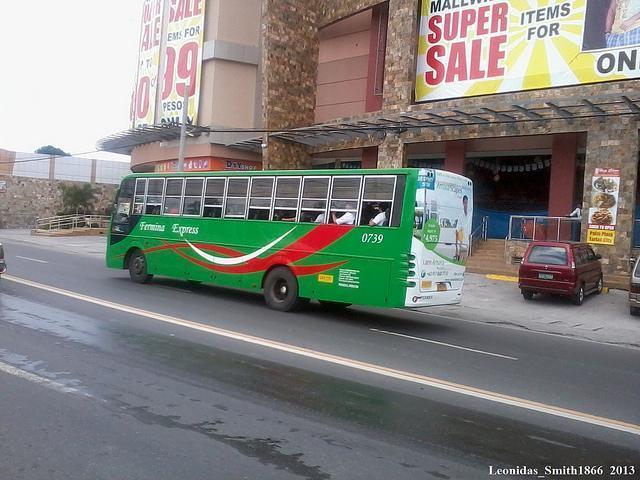How many street signs with a horse in it?
Give a very brief answer. 0. 